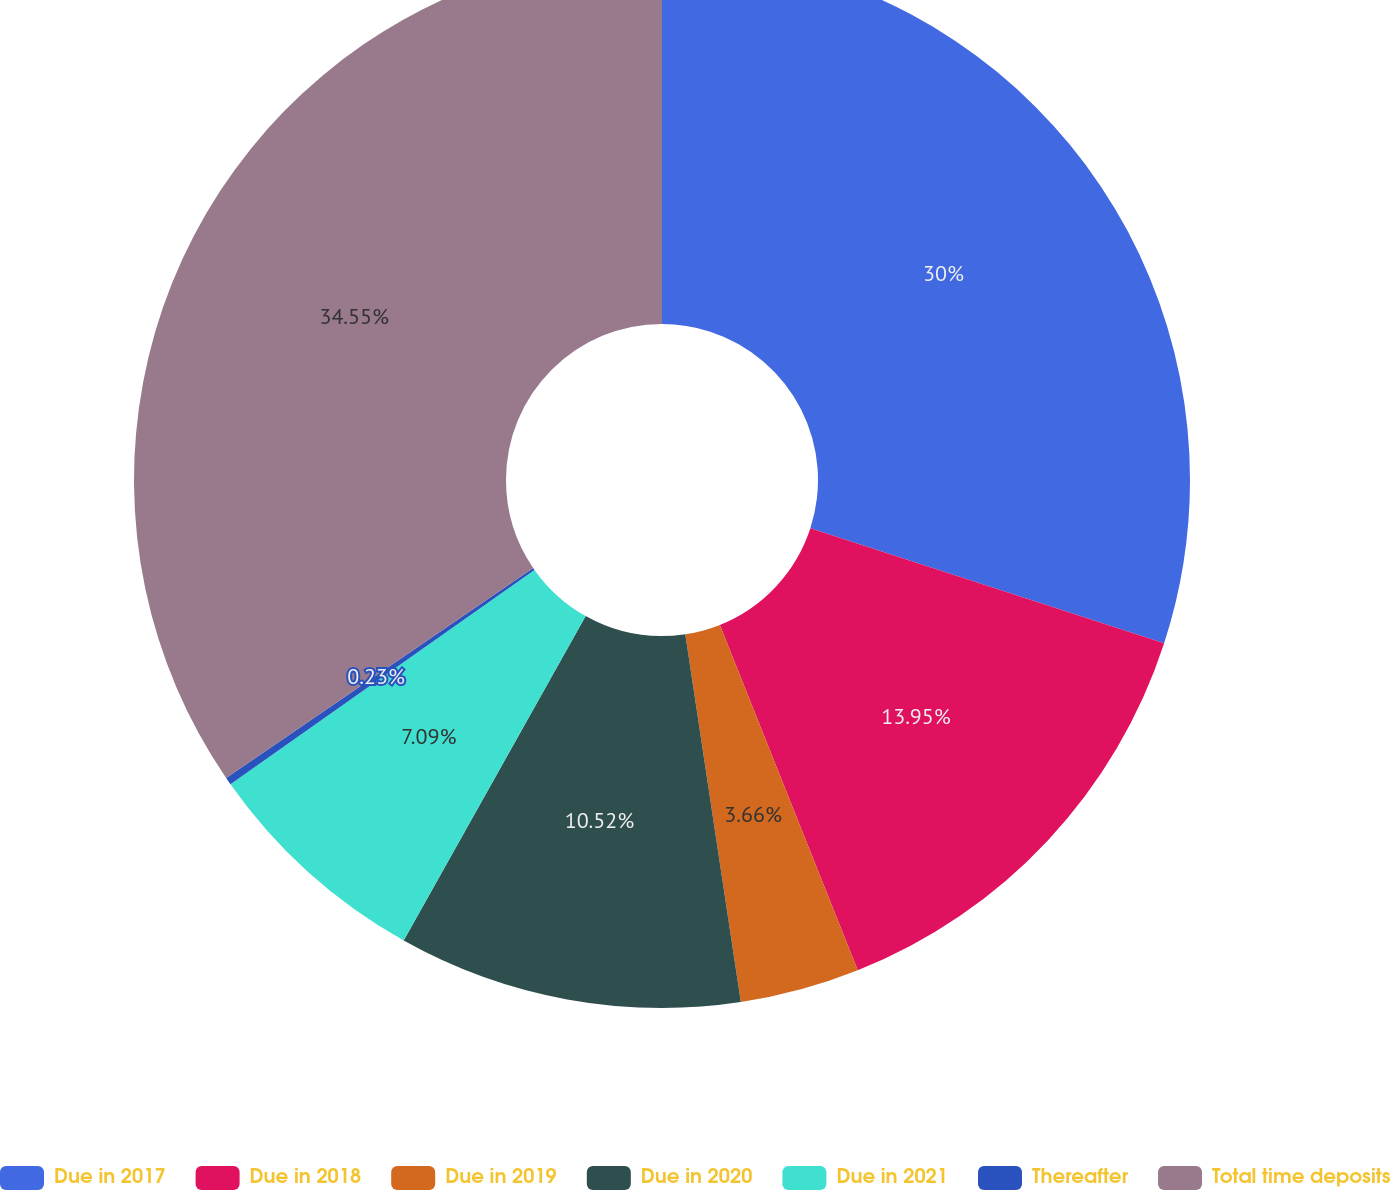<chart> <loc_0><loc_0><loc_500><loc_500><pie_chart><fcel>Due in 2017<fcel>Due in 2018<fcel>Due in 2019<fcel>Due in 2020<fcel>Due in 2021<fcel>Thereafter<fcel>Total time deposits<nl><fcel>30.0%<fcel>13.95%<fcel>3.66%<fcel>10.52%<fcel>7.09%<fcel>0.23%<fcel>34.54%<nl></chart> 